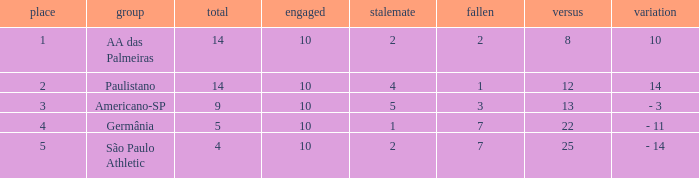What is the total of against when the lost exceeds 7? None. 